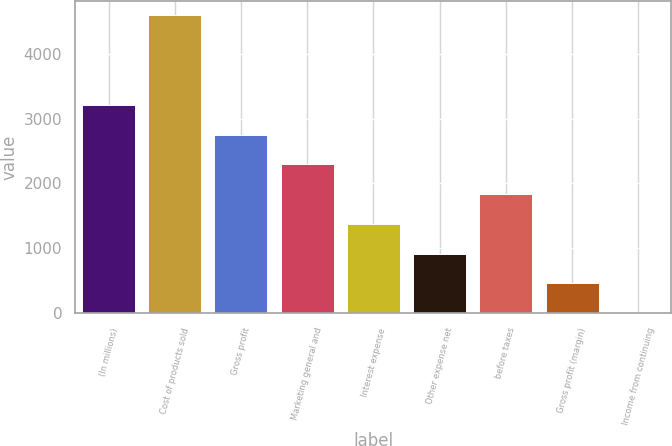Convert chart to OTSL. <chart><loc_0><loc_0><loc_500><loc_500><bar_chart><fcel>(In millions)<fcel>Cost of products sold<fcel>Gross profit<fcel>Marketing general and<fcel>Interest expense<fcel>Other expense net<fcel>before taxes<fcel>Gross profit (margin)<fcel>Income from continuing<nl><fcel>3211.55<fcel>4585.4<fcel>2753.6<fcel>2295.65<fcel>1379.75<fcel>921.8<fcel>1837.7<fcel>463.85<fcel>5.9<nl></chart> 